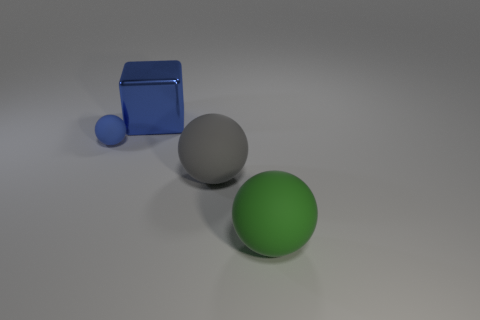What is the color of the matte object that is in front of the gray thing?
Provide a short and direct response. Green. What is the size of the matte ball left of the large object behind the small blue rubber object?
Your answer should be very brief. Small. There is a big object on the left side of the gray object; is it the same shape as the tiny thing?
Ensure brevity in your answer.  No. There is a gray object that is the same shape as the small blue thing; what is it made of?
Provide a succinct answer. Rubber. What number of objects are either objects behind the small matte thing or matte spheres right of the blue rubber ball?
Provide a short and direct response. 3. Do the small ball and the thing that is behind the tiny blue matte sphere have the same color?
Offer a very short reply. Yes. How many purple shiny objects are there?
Offer a very short reply. 0. How many things are either rubber spheres on the right side of the small blue matte ball or tiny blue spheres?
Your answer should be very brief. 3. There is a big matte sphere that is on the left side of the green sphere; does it have the same color as the large shiny object?
Your answer should be compact. No. How many other things are the same color as the large metallic cube?
Your response must be concise. 1. 